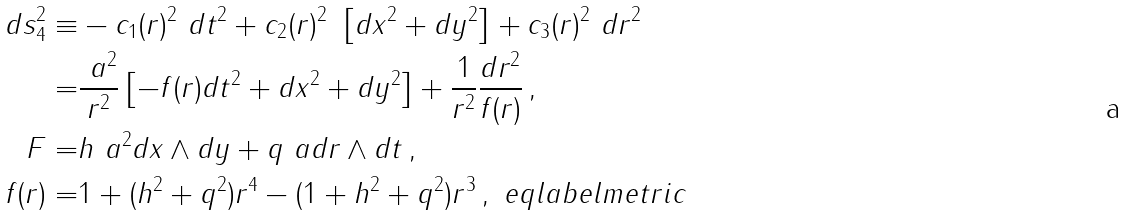<formula> <loc_0><loc_0><loc_500><loc_500>d s ^ { 2 } _ { 4 } \equiv & - c _ { 1 } ( r ) ^ { 2 } \ d t ^ { 2 } + c _ { 2 } ( r ) ^ { 2 } \ \left [ d x ^ { 2 } + d y ^ { 2 } \right ] + c _ { 3 } ( r ) ^ { 2 } \ d r ^ { 2 } \\ = & \frac { \ a ^ { 2 } } { r ^ { 2 } } \left [ - f ( r ) d t ^ { 2 } + d x ^ { 2 } + d y ^ { 2 } \right ] + \frac { 1 } { r ^ { 2 } } \frac { d r ^ { 2 } } { f ( r ) } \, , \\ F = & h \ a ^ { 2 } d x \wedge d y + q \ a d r \wedge d t \, , \\ f ( r ) = & 1 + ( h ^ { 2 } + q ^ { 2 } ) r ^ { 4 } - ( 1 + h ^ { 2 } + q ^ { 2 } ) r ^ { 3 } \, , \ e q l a b e l { m e t r i c }</formula> 